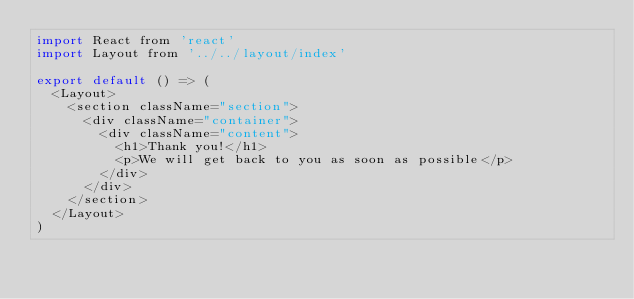Convert code to text. <code><loc_0><loc_0><loc_500><loc_500><_JavaScript_>import React from 'react'
import Layout from '../../layout/index'

export default () => (
  <Layout>
    <section className="section">
      <div className="container">
        <div className="content">
          <h1>Thank you!</h1>
          <p>We will get back to you as soon as possible</p>
        </div>
      </div>
    </section>
  </Layout>
)
</code> 